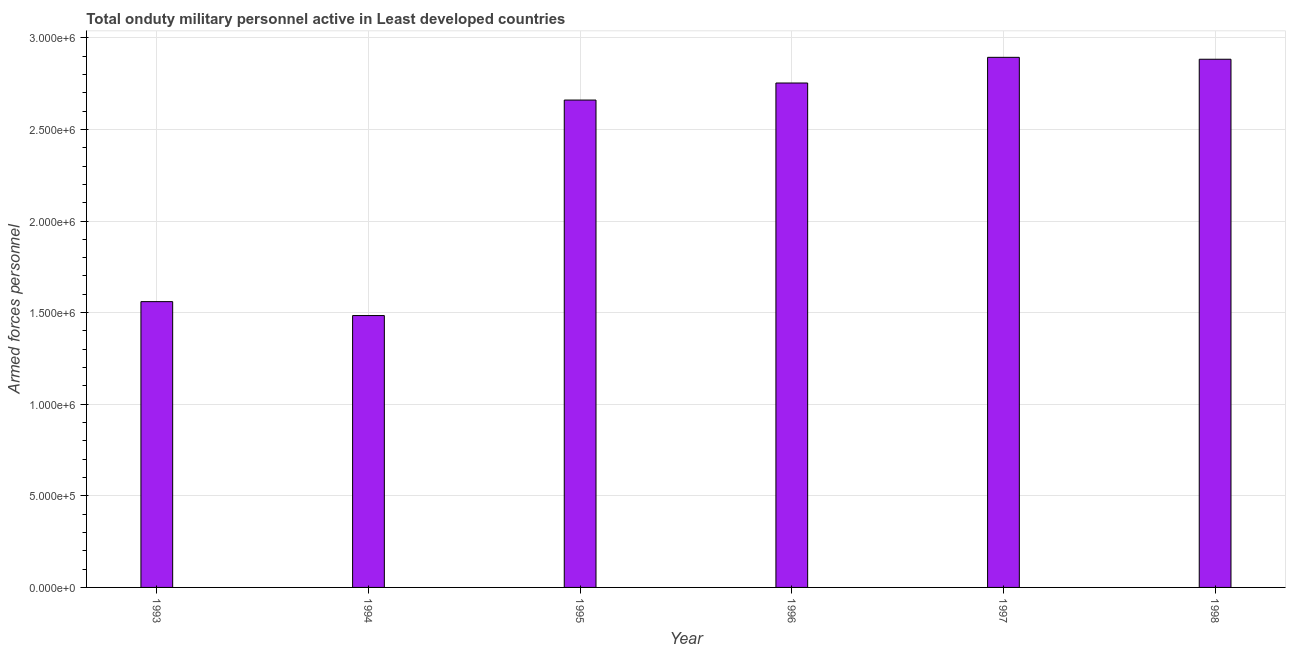What is the title of the graph?
Ensure brevity in your answer.  Total onduty military personnel active in Least developed countries. What is the label or title of the Y-axis?
Ensure brevity in your answer.  Armed forces personnel. What is the number of armed forces personnel in 1994?
Provide a short and direct response. 1.48e+06. Across all years, what is the maximum number of armed forces personnel?
Your answer should be very brief. 2.89e+06. Across all years, what is the minimum number of armed forces personnel?
Keep it short and to the point. 1.48e+06. In which year was the number of armed forces personnel maximum?
Provide a short and direct response. 1997. In which year was the number of armed forces personnel minimum?
Ensure brevity in your answer.  1994. What is the sum of the number of armed forces personnel?
Offer a very short reply. 1.42e+07. What is the difference between the number of armed forces personnel in 1994 and 1997?
Your response must be concise. -1.41e+06. What is the average number of armed forces personnel per year?
Offer a terse response. 2.37e+06. What is the median number of armed forces personnel?
Give a very brief answer. 2.71e+06. What is the ratio of the number of armed forces personnel in 1993 to that in 1997?
Your response must be concise. 0.54. Is the number of armed forces personnel in 1993 less than that in 1995?
Provide a short and direct response. Yes. Is the difference between the number of armed forces personnel in 1996 and 1997 greater than the difference between any two years?
Your answer should be compact. No. What is the difference between the highest and the second highest number of armed forces personnel?
Provide a succinct answer. 1.05e+04. What is the difference between the highest and the lowest number of armed forces personnel?
Make the answer very short. 1.41e+06. In how many years, is the number of armed forces personnel greater than the average number of armed forces personnel taken over all years?
Keep it short and to the point. 4. How many bars are there?
Keep it short and to the point. 6. Are all the bars in the graph horizontal?
Offer a very short reply. No. What is the difference between two consecutive major ticks on the Y-axis?
Provide a short and direct response. 5.00e+05. What is the Armed forces personnel in 1993?
Keep it short and to the point. 1.56e+06. What is the Armed forces personnel in 1994?
Offer a terse response. 1.48e+06. What is the Armed forces personnel in 1995?
Keep it short and to the point. 2.66e+06. What is the Armed forces personnel of 1996?
Give a very brief answer. 2.75e+06. What is the Armed forces personnel in 1997?
Offer a terse response. 2.89e+06. What is the Armed forces personnel of 1998?
Keep it short and to the point. 2.88e+06. What is the difference between the Armed forces personnel in 1993 and 1994?
Ensure brevity in your answer.  7.60e+04. What is the difference between the Armed forces personnel in 1993 and 1995?
Offer a terse response. -1.10e+06. What is the difference between the Armed forces personnel in 1993 and 1996?
Your response must be concise. -1.19e+06. What is the difference between the Armed forces personnel in 1993 and 1997?
Ensure brevity in your answer.  -1.33e+06. What is the difference between the Armed forces personnel in 1993 and 1998?
Provide a short and direct response. -1.32e+06. What is the difference between the Armed forces personnel in 1994 and 1995?
Make the answer very short. -1.18e+06. What is the difference between the Armed forces personnel in 1994 and 1996?
Offer a very short reply. -1.27e+06. What is the difference between the Armed forces personnel in 1994 and 1997?
Ensure brevity in your answer.  -1.41e+06. What is the difference between the Armed forces personnel in 1994 and 1998?
Offer a very short reply. -1.40e+06. What is the difference between the Armed forces personnel in 1995 and 1996?
Your answer should be compact. -9.31e+04. What is the difference between the Armed forces personnel in 1995 and 1997?
Your answer should be very brief. -2.33e+05. What is the difference between the Armed forces personnel in 1995 and 1998?
Offer a very short reply. -2.23e+05. What is the difference between the Armed forces personnel in 1996 and 1997?
Offer a very short reply. -1.40e+05. What is the difference between the Armed forces personnel in 1996 and 1998?
Provide a short and direct response. -1.30e+05. What is the difference between the Armed forces personnel in 1997 and 1998?
Make the answer very short. 1.05e+04. What is the ratio of the Armed forces personnel in 1993 to that in 1994?
Make the answer very short. 1.05. What is the ratio of the Armed forces personnel in 1993 to that in 1995?
Give a very brief answer. 0.59. What is the ratio of the Armed forces personnel in 1993 to that in 1996?
Your response must be concise. 0.57. What is the ratio of the Armed forces personnel in 1993 to that in 1997?
Offer a very short reply. 0.54. What is the ratio of the Armed forces personnel in 1993 to that in 1998?
Offer a very short reply. 0.54. What is the ratio of the Armed forces personnel in 1994 to that in 1995?
Your answer should be very brief. 0.56. What is the ratio of the Armed forces personnel in 1994 to that in 1996?
Your answer should be compact. 0.54. What is the ratio of the Armed forces personnel in 1994 to that in 1997?
Provide a succinct answer. 0.51. What is the ratio of the Armed forces personnel in 1994 to that in 1998?
Ensure brevity in your answer.  0.52. What is the ratio of the Armed forces personnel in 1995 to that in 1996?
Your response must be concise. 0.97. What is the ratio of the Armed forces personnel in 1995 to that in 1997?
Provide a succinct answer. 0.92. What is the ratio of the Armed forces personnel in 1995 to that in 1998?
Keep it short and to the point. 0.92. What is the ratio of the Armed forces personnel in 1996 to that in 1998?
Your response must be concise. 0.95. What is the ratio of the Armed forces personnel in 1997 to that in 1998?
Give a very brief answer. 1. 